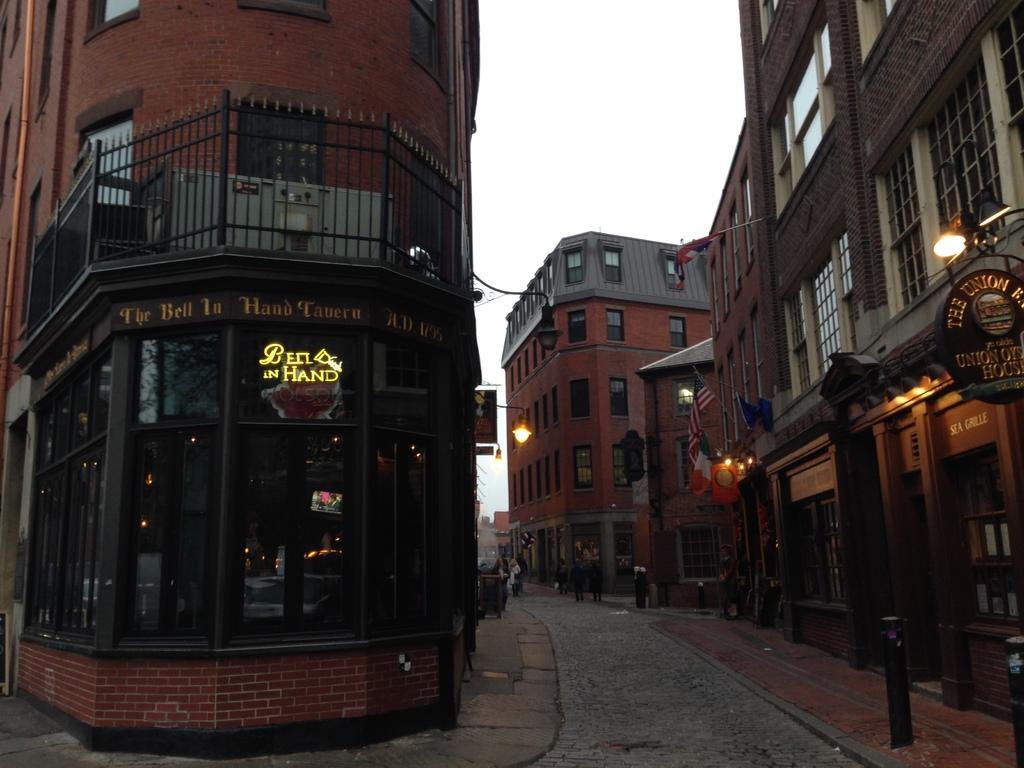Describe this image in one or two sentences. There is a road. On the sides of the road there are sidewalks and buildings with windows, glass walls, railings. Also there are name boards and flags. In the background there is sky. 